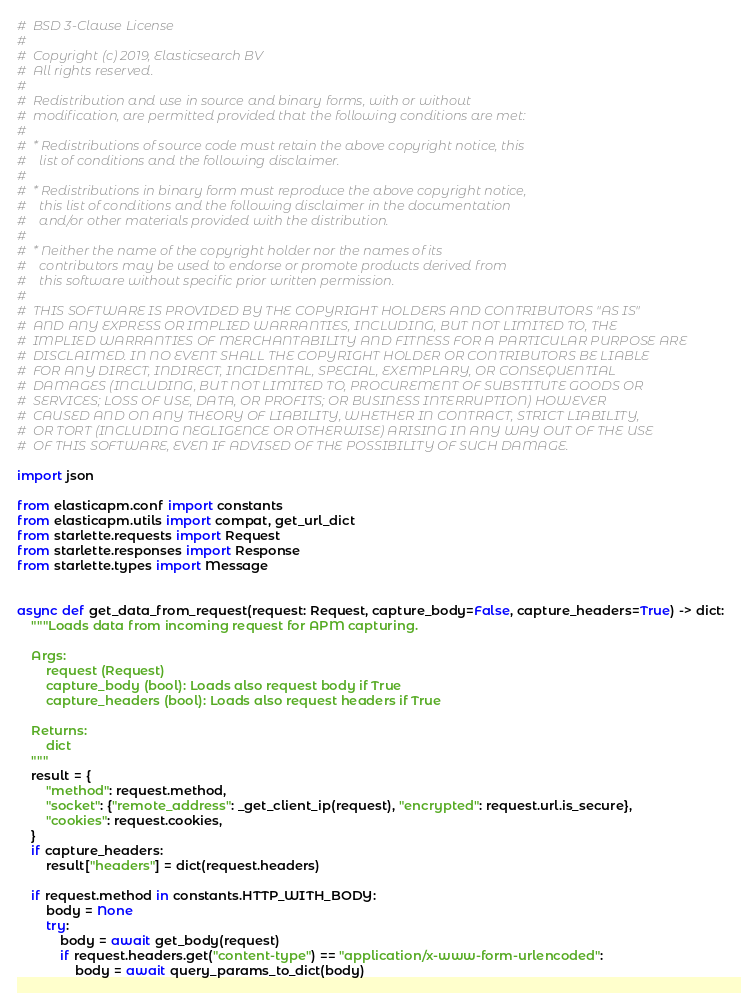<code> <loc_0><loc_0><loc_500><loc_500><_Python_>#  BSD 3-Clause License
#
#  Copyright (c) 2019, Elasticsearch BV
#  All rights reserved.
#
#  Redistribution and use in source and binary forms, with or without
#  modification, are permitted provided that the following conditions are met:
#
#  * Redistributions of source code must retain the above copyright notice, this
#    list of conditions and the following disclaimer.
#
#  * Redistributions in binary form must reproduce the above copyright notice,
#    this list of conditions and the following disclaimer in the documentation
#    and/or other materials provided with the distribution.
#
#  * Neither the name of the copyright holder nor the names of its
#    contributors may be used to endorse or promote products derived from
#    this software without specific prior written permission.
#
#  THIS SOFTWARE IS PROVIDED BY THE COPYRIGHT HOLDERS AND CONTRIBUTORS "AS IS"
#  AND ANY EXPRESS OR IMPLIED WARRANTIES, INCLUDING, BUT NOT LIMITED TO, THE
#  IMPLIED WARRANTIES OF MERCHANTABILITY AND FITNESS FOR A PARTICULAR PURPOSE ARE
#  DISCLAIMED. IN NO EVENT SHALL THE COPYRIGHT HOLDER OR CONTRIBUTORS BE LIABLE
#  FOR ANY DIRECT, INDIRECT, INCIDENTAL, SPECIAL, EXEMPLARY, OR CONSEQUENTIAL
#  DAMAGES (INCLUDING, BUT NOT LIMITED TO, PROCUREMENT OF SUBSTITUTE GOODS OR
#  SERVICES; LOSS OF USE, DATA, OR PROFITS; OR BUSINESS INTERRUPTION) HOWEVER
#  CAUSED AND ON ANY THEORY OF LIABILITY, WHETHER IN CONTRACT, STRICT LIABILITY,
#  OR TORT (INCLUDING NEGLIGENCE OR OTHERWISE) ARISING IN ANY WAY OUT OF THE USE
#  OF THIS SOFTWARE, EVEN IF ADVISED OF THE POSSIBILITY OF SUCH DAMAGE.

import json

from elasticapm.conf import constants
from elasticapm.utils import compat, get_url_dict
from starlette.requests import Request
from starlette.responses import Response
from starlette.types import Message


async def get_data_from_request(request: Request, capture_body=False, capture_headers=True) -> dict:
    """Loads data from incoming request for APM capturing.

    Args:
        request (Request)
        capture_body (bool): Loads also request body if True
        capture_headers (bool): Loads also request headers if True

    Returns:
        dict
    """
    result = {
        "method": request.method,
        "socket": {"remote_address": _get_client_ip(request), "encrypted": request.url.is_secure},
        "cookies": request.cookies,
    }
    if capture_headers:
        result["headers"] = dict(request.headers)

    if request.method in constants.HTTP_WITH_BODY:
        body = None
        try:
            body = await get_body(request)
            if request.headers.get("content-type") == "application/x-www-form-urlencoded":
                body = await query_params_to_dict(body)</code> 